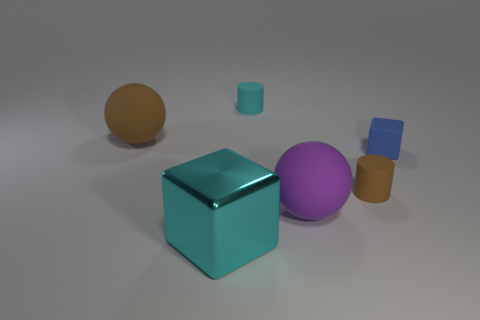Add 1 big red matte cylinders. How many objects exist? 7 Subtract all balls. How many objects are left? 4 Subtract 0 red balls. How many objects are left? 6 Subtract all large purple metallic things. Subtract all large purple matte spheres. How many objects are left? 5 Add 5 small blue cubes. How many small blue cubes are left? 6 Add 1 big cyan matte spheres. How many big cyan matte spheres exist? 1 